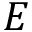<formula> <loc_0><loc_0><loc_500><loc_500>E</formula> 